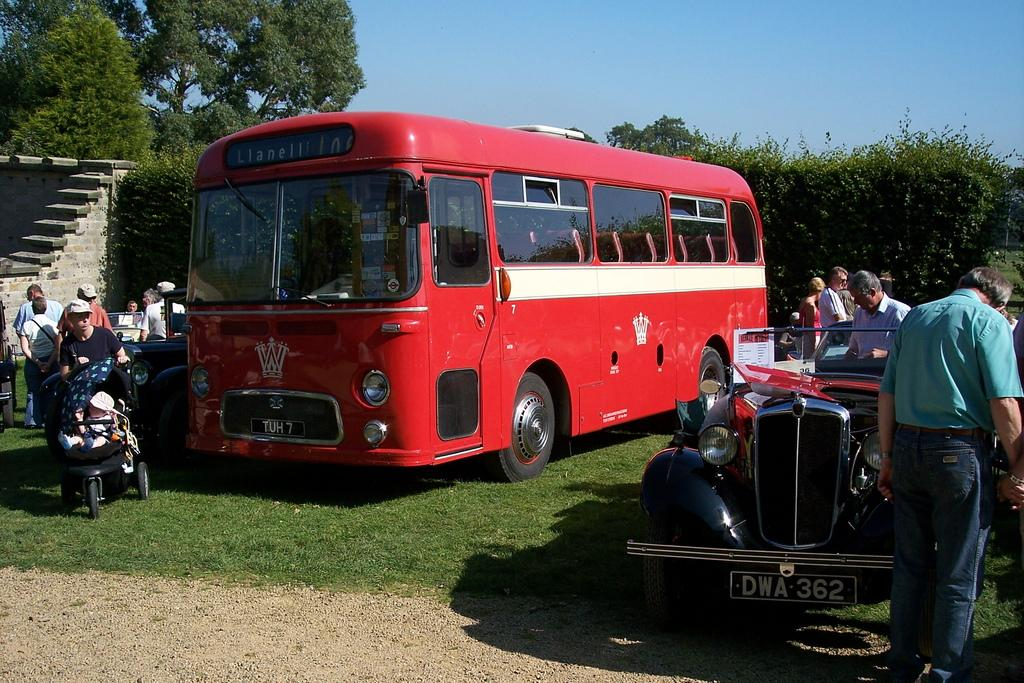How many people can be seen in the image? There are many people in the image. What vehicles are present in the image? There is a bus and a car in the image. Where are the people located in relation to the car? People are inside the car. What type of vegetation is near the people? There are trees near the people. What is the condition of the sky in the image? The sky is clear and visible in the image. Can you see any amusement rides in the image? There are no amusement rides present in the image. Is there any steam coming from the car in the image? There is no steam visible in the image. 